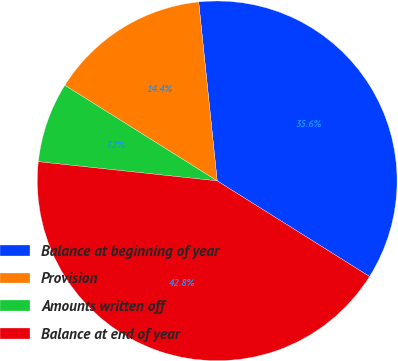<chart> <loc_0><loc_0><loc_500><loc_500><pie_chart><fcel>Balance at beginning of year<fcel>Provision<fcel>Amounts written off<fcel>Balance at end of year<nl><fcel>35.56%<fcel>14.44%<fcel>7.22%<fcel>42.78%<nl></chart> 